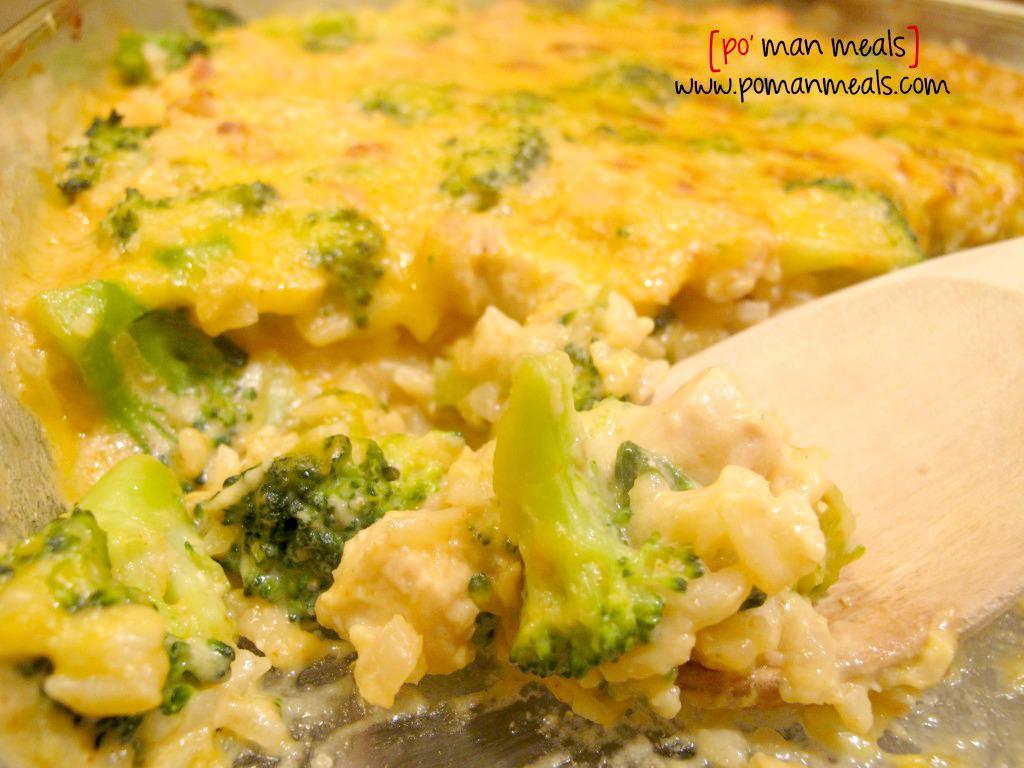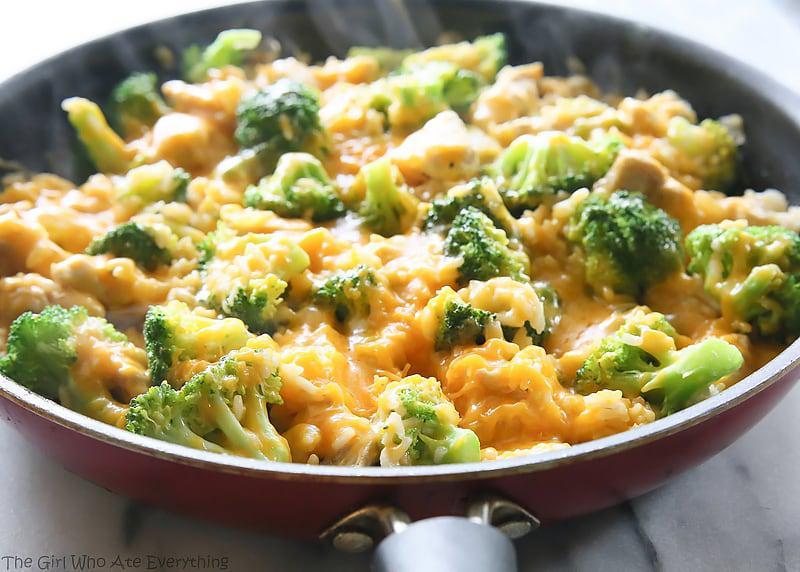The first image is the image on the left, the second image is the image on the right. Evaluate the accuracy of this statement regarding the images: "A meal is served on a red container.". Is it true? Answer yes or no. Yes. 